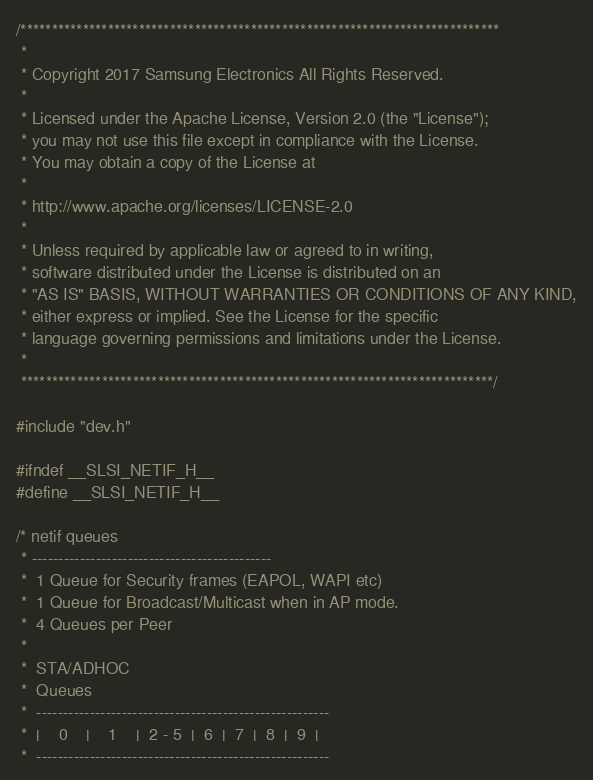Convert code to text. <code><loc_0><loc_0><loc_500><loc_500><_C_>/*****************************************************************************
 *
 * Copyright 2017 Samsung Electronics All Rights Reserved.
 *
 * Licensed under the Apache License, Version 2.0 (the "License");
 * you may not use this file except in compliance with the License.
 * You may obtain a copy of the License at
 *
 * http://www.apache.org/licenses/LICENSE-2.0
 *
 * Unless required by applicable law or agreed to in writing,
 * software distributed under the License is distributed on an
 * "AS IS" BASIS, WITHOUT WARRANTIES OR CONDITIONS OF ANY KIND,
 * either express or implied. See the License for the specific
 * language governing permissions and limitations under the License.
 *
 ****************************************************************************/

#include "dev.h"

#ifndef __SLSI_NETIF_H__
#define __SLSI_NETIF_H__

/* netif queues
 * ---------------------------------------------
 *	1 Queue for Security frames (EAPOL, WAPI etc)
 *	1 Queue for Broadcast/Multicast when in AP mode.
 *	4 Queues per Peer
 *
 *	STA/ADHOC
 *	Queues
 *	-------------------------------------------------------
 *	|    0    |    1    |  2 - 5  |  6  |  7  |  8  |  9  |
 *	-------------------------------------------------------</code> 